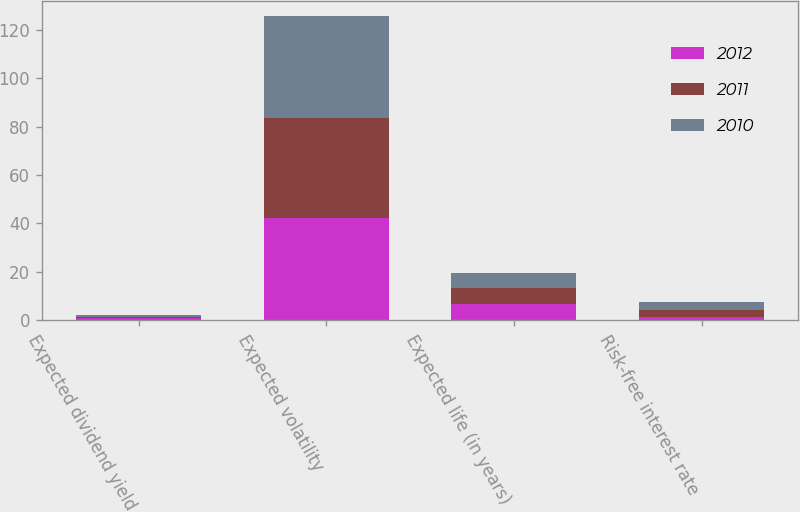Convert chart. <chart><loc_0><loc_0><loc_500><loc_500><stacked_bar_chart><ecel><fcel>Expected dividend yield<fcel>Expected volatility<fcel>Expected life (in years)<fcel>Risk-free interest rate<nl><fcel>2012<fcel>0.63<fcel>42.09<fcel>6.5<fcel>1.3<nl><fcel>2011<fcel>0.61<fcel>41.61<fcel>6.5<fcel>2.84<nl><fcel>2010<fcel>0.87<fcel>42.17<fcel>6.5<fcel>3.13<nl></chart> 